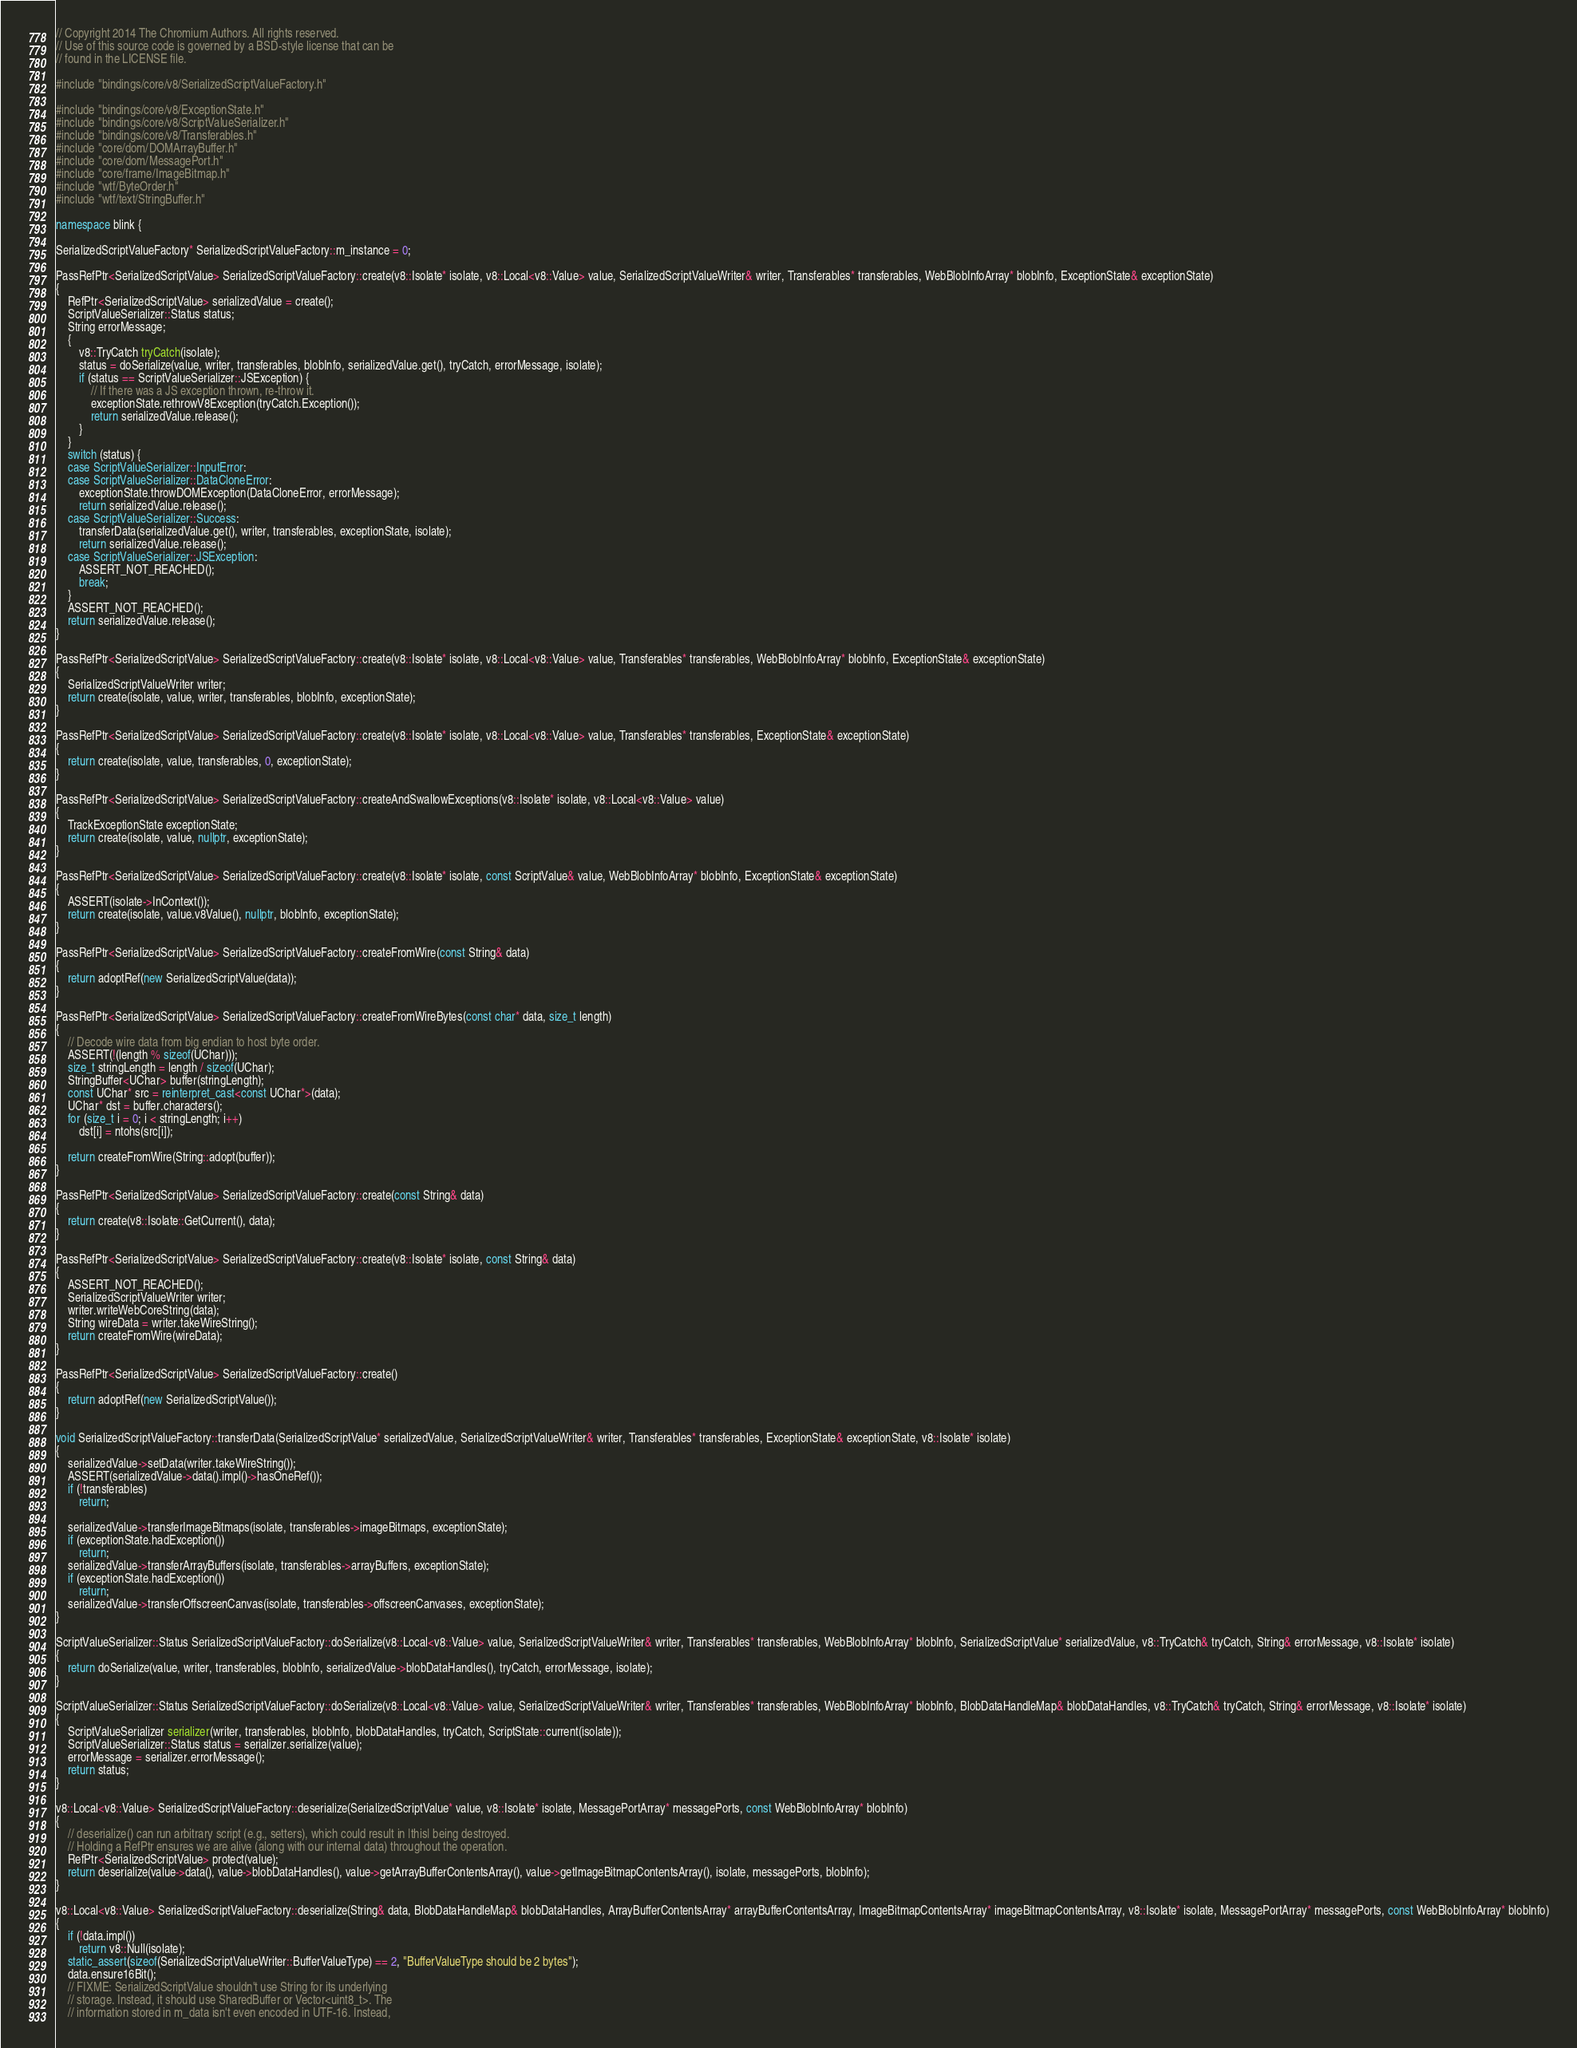Convert code to text. <code><loc_0><loc_0><loc_500><loc_500><_C++_>// Copyright 2014 The Chromium Authors. All rights reserved.
// Use of this source code is governed by a BSD-style license that can be
// found in the LICENSE file.

#include "bindings/core/v8/SerializedScriptValueFactory.h"

#include "bindings/core/v8/ExceptionState.h"
#include "bindings/core/v8/ScriptValueSerializer.h"
#include "bindings/core/v8/Transferables.h"
#include "core/dom/DOMArrayBuffer.h"
#include "core/dom/MessagePort.h"
#include "core/frame/ImageBitmap.h"
#include "wtf/ByteOrder.h"
#include "wtf/text/StringBuffer.h"

namespace blink {

SerializedScriptValueFactory* SerializedScriptValueFactory::m_instance = 0;

PassRefPtr<SerializedScriptValue> SerializedScriptValueFactory::create(v8::Isolate* isolate, v8::Local<v8::Value> value, SerializedScriptValueWriter& writer, Transferables* transferables, WebBlobInfoArray* blobInfo, ExceptionState& exceptionState)
{
    RefPtr<SerializedScriptValue> serializedValue = create();
    ScriptValueSerializer::Status status;
    String errorMessage;
    {
        v8::TryCatch tryCatch(isolate);
        status = doSerialize(value, writer, transferables, blobInfo, serializedValue.get(), tryCatch, errorMessage, isolate);
        if (status == ScriptValueSerializer::JSException) {
            // If there was a JS exception thrown, re-throw it.
            exceptionState.rethrowV8Exception(tryCatch.Exception());
            return serializedValue.release();
        }
    }
    switch (status) {
    case ScriptValueSerializer::InputError:
    case ScriptValueSerializer::DataCloneError:
        exceptionState.throwDOMException(DataCloneError, errorMessage);
        return serializedValue.release();
    case ScriptValueSerializer::Success:
        transferData(serializedValue.get(), writer, transferables, exceptionState, isolate);
        return serializedValue.release();
    case ScriptValueSerializer::JSException:
        ASSERT_NOT_REACHED();
        break;
    }
    ASSERT_NOT_REACHED();
    return serializedValue.release();
}

PassRefPtr<SerializedScriptValue> SerializedScriptValueFactory::create(v8::Isolate* isolate, v8::Local<v8::Value> value, Transferables* transferables, WebBlobInfoArray* blobInfo, ExceptionState& exceptionState)
{
    SerializedScriptValueWriter writer;
    return create(isolate, value, writer, transferables, blobInfo, exceptionState);
}

PassRefPtr<SerializedScriptValue> SerializedScriptValueFactory::create(v8::Isolate* isolate, v8::Local<v8::Value> value, Transferables* transferables, ExceptionState& exceptionState)
{
    return create(isolate, value, transferables, 0, exceptionState);
}

PassRefPtr<SerializedScriptValue> SerializedScriptValueFactory::createAndSwallowExceptions(v8::Isolate* isolate, v8::Local<v8::Value> value)
{
    TrackExceptionState exceptionState;
    return create(isolate, value, nullptr, exceptionState);
}

PassRefPtr<SerializedScriptValue> SerializedScriptValueFactory::create(v8::Isolate* isolate, const ScriptValue& value, WebBlobInfoArray* blobInfo, ExceptionState& exceptionState)
{
    ASSERT(isolate->InContext());
    return create(isolate, value.v8Value(), nullptr, blobInfo, exceptionState);
}

PassRefPtr<SerializedScriptValue> SerializedScriptValueFactory::createFromWire(const String& data)
{
    return adoptRef(new SerializedScriptValue(data));
}

PassRefPtr<SerializedScriptValue> SerializedScriptValueFactory::createFromWireBytes(const char* data, size_t length)
{
    // Decode wire data from big endian to host byte order.
    ASSERT(!(length % sizeof(UChar)));
    size_t stringLength = length / sizeof(UChar);
    StringBuffer<UChar> buffer(stringLength);
    const UChar* src = reinterpret_cast<const UChar*>(data);
    UChar* dst = buffer.characters();
    for (size_t i = 0; i < stringLength; i++)
        dst[i] = ntohs(src[i]);

    return createFromWire(String::adopt(buffer));
}

PassRefPtr<SerializedScriptValue> SerializedScriptValueFactory::create(const String& data)
{
    return create(v8::Isolate::GetCurrent(), data);
}

PassRefPtr<SerializedScriptValue> SerializedScriptValueFactory::create(v8::Isolate* isolate, const String& data)
{
    ASSERT_NOT_REACHED();
    SerializedScriptValueWriter writer;
    writer.writeWebCoreString(data);
    String wireData = writer.takeWireString();
    return createFromWire(wireData);
}

PassRefPtr<SerializedScriptValue> SerializedScriptValueFactory::create()
{
    return adoptRef(new SerializedScriptValue());
}

void SerializedScriptValueFactory::transferData(SerializedScriptValue* serializedValue, SerializedScriptValueWriter& writer, Transferables* transferables, ExceptionState& exceptionState, v8::Isolate* isolate)
{
    serializedValue->setData(writer.takeWireString());
    ASSERT(serializedValue->data().impl()->hasOneRef());
    if (!transferables)
        return;

    serializedValue->transferImageBitmaps(isolate, transferables->imageBitmaps, exceptionState);
    if (exceptionState.hadException())
        return;
    serializedValue->transferArrayBuffers(isolate, transferables->arrayBuffers, exceptionState);
    if (exceptionState.hadException())
        return;
    serializedValue->transferOffscreenCanvas(isolate, transferables->offscreenCanvases, exceptionState);
}

ScriptValueSerializer::Status SerializedScriptValueFactory::doSerialize(v8::Local<v8::Value> value, SerializedScriptValueWriter& writer, Transferables* transferables, WebBlobInfoArray* blobInfo, SerializedScriptValue* serializedValue, v8::TryCatch& tryCatch, String& errorMessage, v8::Isolate* isolate)
{
    return doSerialize(value, writer, transferables, blobInfo, serializedValue->blobDataHandles(), tryCatch, errorMessage, isolate);
}

ScriptValueSerializer::Status SerializedScriptValueFactory::doSerialize(v8::Local<v8::Value> value, SerializedScriptValueWriter& writer, Transferables* transferables, WebBlobInfoArray* blobInfo, BlobDataHandleMap& blobDataHandles, v8::TryCatch& tryCatch, String& errorMessage, v8::Isolate* isolate)
{
    ScriptValueSerializer serializer(writer, transferables, blobInfo, blobDataHandles, tryCatch, ScriptState::current(isolate));
    ScriptValueSerializer::Status status = serializer.serialize(value);
    errorMessage = serializer.errorMessage();
    return status;
}

v8::Local<v8::Value> SerializedScriptValueFactory::deserialize(SerializedScriptValue* value, v8::Isolate* isolate, MessagePortArray* messagePorts, const WebBlobInfoArray* blobInfo)
{
    // deserialize() can run arbitrary script (e.g., setters), which could result in |this| being destroyed.
    // Holding a RefPtr ensures we are alive (along with our internal data) throughout the operation.
    RefPtr<SerializedScriptValue> protect(value);
    return deserialize(value->data(), value->blobDataHandles(), value->getArrayBufferContentsArray(), value->getImageBitmapContentsArray(), isolate, messagePorts, blobInfo);
}

v8::Local<v8::Value> SerializedScriptValueFactory::deserialize(String& data, BlobDataHandleMap& blobDataHandles, ArrayBufferContentsArray* arrayBufferContentsArray, ImageBitmapContentsArray* imageBitmapContentsArray, v8::Isolate* isolate, MessagePortArray* messagePorts, const WebBlobInfoArray* blobInfo)
{
    if (!data.impl())
        return v8::Null(isolate);
    static_assert(sizeof(SerializedScriptValueWriter::BufferValueType) == 2, "BufferValueType should be 2 bytes");
    data.ensure16Bit();
    // FIXME: SerializedScriptValue shouldn't use String for its underlying
    // storage. Instead, it should use SharedBuffer or Vector<uint8_t>. The
    // information stored in m_data isn't even encoded in UTF-16. Instead,</code> 